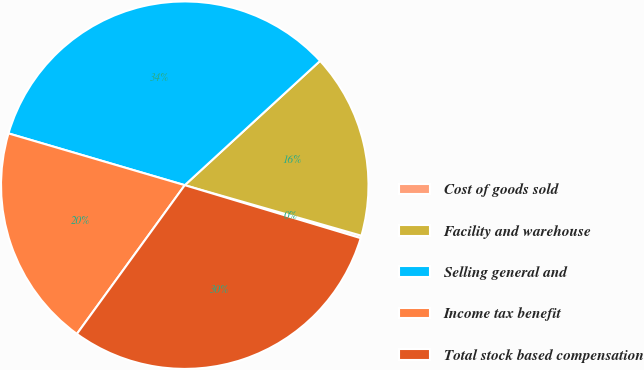Convert chart. <chart><loc_0><loc_0><loc_500><loc_500><pie_chart><fcel>Cost of goods sold<fcel>Facility and warehouse<fcel>Selling general and<fcel>Income tax benefit<fcel>Total stock based compensation<nl><fcel>0.22%<fcel>16.26%<fcel>33.63%<fcel>19.56%<fcel>30.33%<nl></chart> 